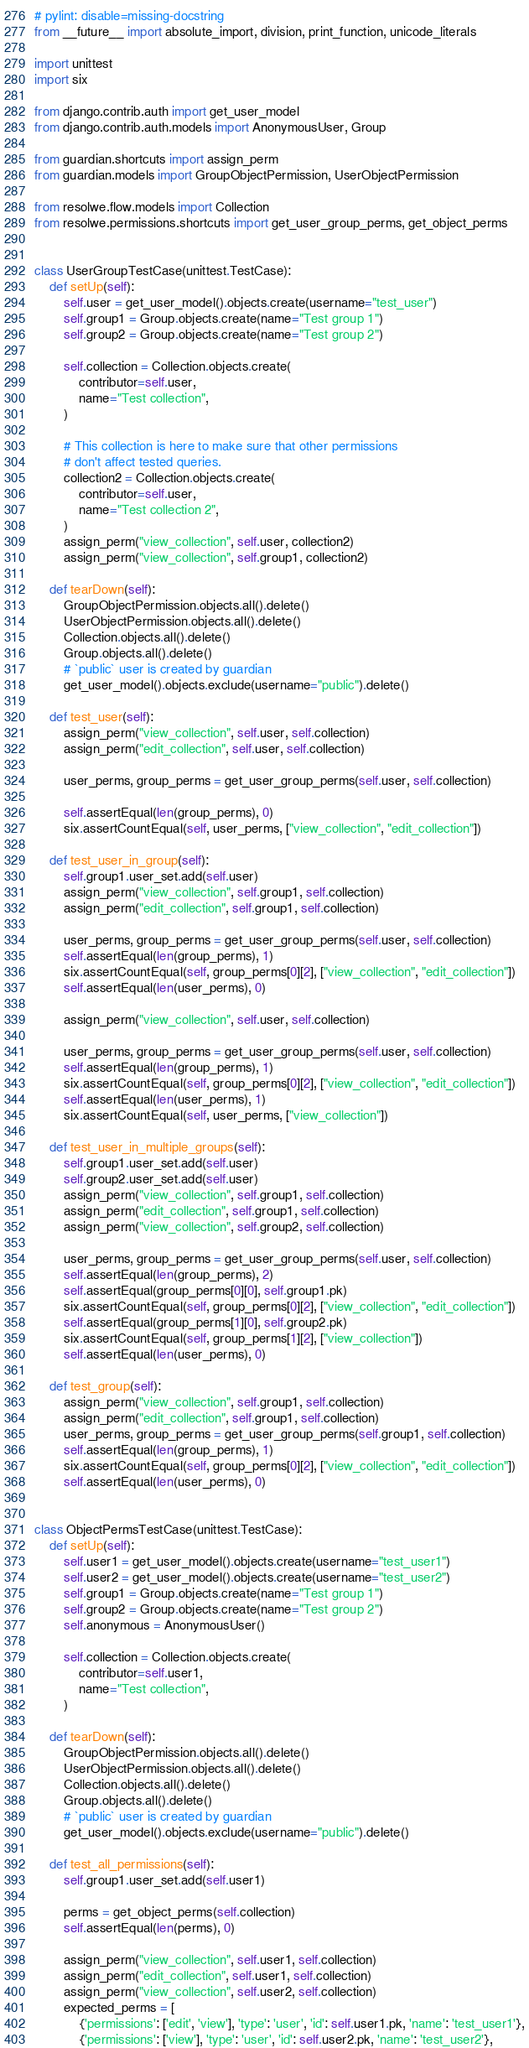Convert code to text. <code><loc_0><loc_0><loc_500><loc_500><_Python_># pylint: disable=missing-docstring
from __future__ import absolute_import, division, print_function, unicode_literals

import unittest
import six

from django.contrib.auth import get_user_model
from django.contrib.auth.models import AnonymousUser, Group

from guardian.shortcuts import assign_perm
from guardian.models import GroupObjectPermission, UserObjectPermission

from resolwe.flow.models import Collection
from resolwe.permissions.shortcuts import get_user_group_perms, get_object_perms


class UserGroupTestCase(unittest.TestCase):
    def setUp(self):
        self.user = get_user_model().objects.create(username="test_user")
        self.group1 = Group.objects.create(name="Test group 1")
        self.group2 = Group.objects.create(name="Test group 2")

        self.collection = Collection.objects.create(
            contributor=self.user,
            name="Test collection",
        )

        # This collection is here to make sure that other permissions
        # don't affect tested queries.
        collection2 = Collection.objects.create(
            contributor=self.user,
            name="Test collection 2",
        )
        assign_perm("view_collection", self.user, collection2)
        assign_perm("view_collection", self.group1, collection2)

    def tearDown(self):
        GroupObjectPermission.objects.all().delete()
        UserObjectPermission.objects.all().delete()
        Collection.objects.all().delete()
        Group.objects.all().delete()
        # `public` user is created by guardian
        get_user_model().objects.exclude(username="public").delete()

    def test_user(self):
        assign_perm("view_collection", self.user, self.collection)
        assign_perm("edit_collection", self.user, self.collection)

        user_perms, group_perms = get_user_group_perms(self.user, self.collection)

        self.assertEqual(len(group_perms), 0)
        six.assertCountEqual(self, user_perms, ["view_collection", "edit_collection"])

    def test_user_in_group(self):
        self.group1.user_set.add(self.user)
        assign_perm("view_collection", self.group1, self.collection)
        assign_perm("edit_collection", self.group1, self.collection)

        user_perms, group_perms = get_user_group_perms(self.user, self.collection)
        self.assertEqual(len(group_perms), 1)
        six.assertCountEqual(self, group_perms[0][2], ["view_collection", "edit_collection"])
        self.assertEqual(len(user_perms), 0)

        assign_perm("view_collection", self.user, self.collection)

        user_perms, group_perms = get_user_group_perms(self.user, self.collection)
        self.assertEqual(len(group_perms), 1)
        six.assertCountEqual(self, group_perms[0][2], ["view_collection", "edit_collection"])
        self.assertEqual(len(user_perms), 1)
        six.assertCountEqual(self, user_perms, ["view_collection"])

    def test_user_in_multiple_groups(self):
        self.group1.user_set.add(self.user)
        self.group2.user_set.add(self.user)
        assign_perm("view_collection", self.group1, self.collection)
        assign_perm("edit_collection", self.group1, self.collection)
        assign_perm("view_collection", self.group2, self.collection)

        user_perms, group_perms = get_user_group_perms(self.user, self.collection)
        self.assertEqual(len(group_perms), 2)
        self.assertEqual(group_perms[0][0], self.group1.pk)
        six.assertCountEqual(self, group_perms[0][2], ["view_collection", "edit_collection"])
        self.assertEqual(group_perms[1][0], self.group2.pk)
        six.assertCountEqual(self, group_perms[1][2], ["view_collection"])
        self.assertEqual(len(user_perms), 0)

    def test_group(self):
        assign_perm("view_collection", self.group1, self.collection)
        assign_perm("edit_collection", self.group1, self.collection)
        user_perms, group_perms = get_user_group_perms(self.group1, self.collection)
        self.assertEqual(len(group_perms), 1)
        six.assertCountEqual(self, group_perms[0][2], ["view_collection", "edit_collection"])
        self.assertEqual(len(user_perms), 0)


class ObjectPermsTestCase(unittest.TestCase):
    def setUp(self):
        self.user1 = get_user_model().objects.create(username="test_user1")
        self.user2 = get_user_model().objects.create(username="test_user2")
        self.group1 = Group.objects.create(name="Test group 1")
        self.group2 = Group.objects.create(name="Test group 2")
        self.anonymous = AnonymousUser()

        self.collection = Collection.objects.create(
            contributor=self.user1,
            name="Test collection",
        )

    def tearDown(self):
        GroupObjectPermission.objects.all().delete()
        UserObjectPermission.objects.all().delete()
        Collection.objects.all().delete()
        Group.objects.all().delete()
        # `public` user is created by guardian
        get_user_model().objects.exclude(username="public").delete()

    def test_all_permissions(self):
        self.group1.user_set.add(self.user1)

        perms = get_object_perms(self.collection)
        self.assertEqual(len(perms), 0)

        assign_perm("view_collection", self.user1, self.collection)
        assign_perm("edit_collection", self.user1, self.collection)
        assign_perm("view_collection", self.user2, self.collection)
        expected_perms = [
            {'permissions': ['edit', 'view'], 'type': 'user', 'id': self.user1.pk, 'name': 'test_user1'},
            {'permissions': ['view'], 'type': 'user', 'id': self.user2.pk, 'name': 'test_user2'},</code> 